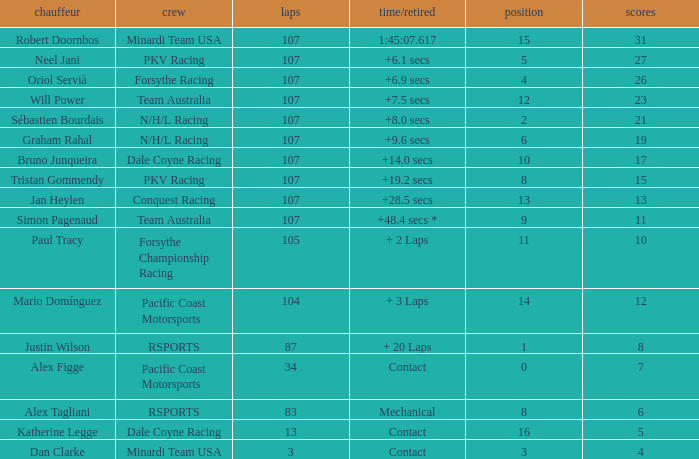What is the highest number of points scored by minardi team usa in more than 13 laps? 31.0. Can you parse all the data within this table? {'header': ['chauffeur', 'crew', 'laps', 'time/retired', 'position', 'scores'], 'rows': [['Robert Doornbos', 'Minardi Team USA', '107', '1:45:07.617', '15', '31'], ['Neel Jani', 'PKV Racing', '107', '+6.1 secs', '5', '27'], ['Oriol Servià', 'Forsythe Racing', '107', '+6.9 secs', '4', '26'], ['Will Power', 'Team Australia', '107', '+7.5 secs', '12', '23'], ['Sébastien Bourdais', 'N/H/L Racing', '107', '+8.0 secs', '2', '21'], ['Graham Rahal', 'N/H/L Racing', '107', '+9.6 secs', '6', '19'], ['Bruno Junqueira', 'Dale Coyne Racing', '107', '+14.0 secs', '10', '17'], ['Tristan Gommendy', 'PKV Racing', '107', '+19.2 secs', '8', '15'], ['Jan Heylen', 'Conquest Racing', '107', '+28.5 secs', '13', '13'], ['Simon Pagenaud', 'Team Australia', '107', '+48.4 secs *', '9', '11'], ['Paul Tracy', 'Forsythe Championship Racing', '105', '+ 2 Laps', '11', '10'], ['Mario Domínguez', 'Pacific Coast Motorsports', '104', '+ 3 Laps', '14', '12'], ['Justin Wilson', 'RSPORTS', '87', '+ 20 Laps', '1', '8'], ['Alex Figge', 'Pacific Coast Motorsports', '34', 'Contact', '0', '7'], ['Alex Tagliani', 'RSPORTS', '83', 'Mechanical', '8', '6'], ['Katherine Legge', 'Dale Coyne Racing', '13', 'Contact', '16', '5'], ['Dan Clarke', 'Minardi Team USA', '3', 'Contact', '3', '4']]} 